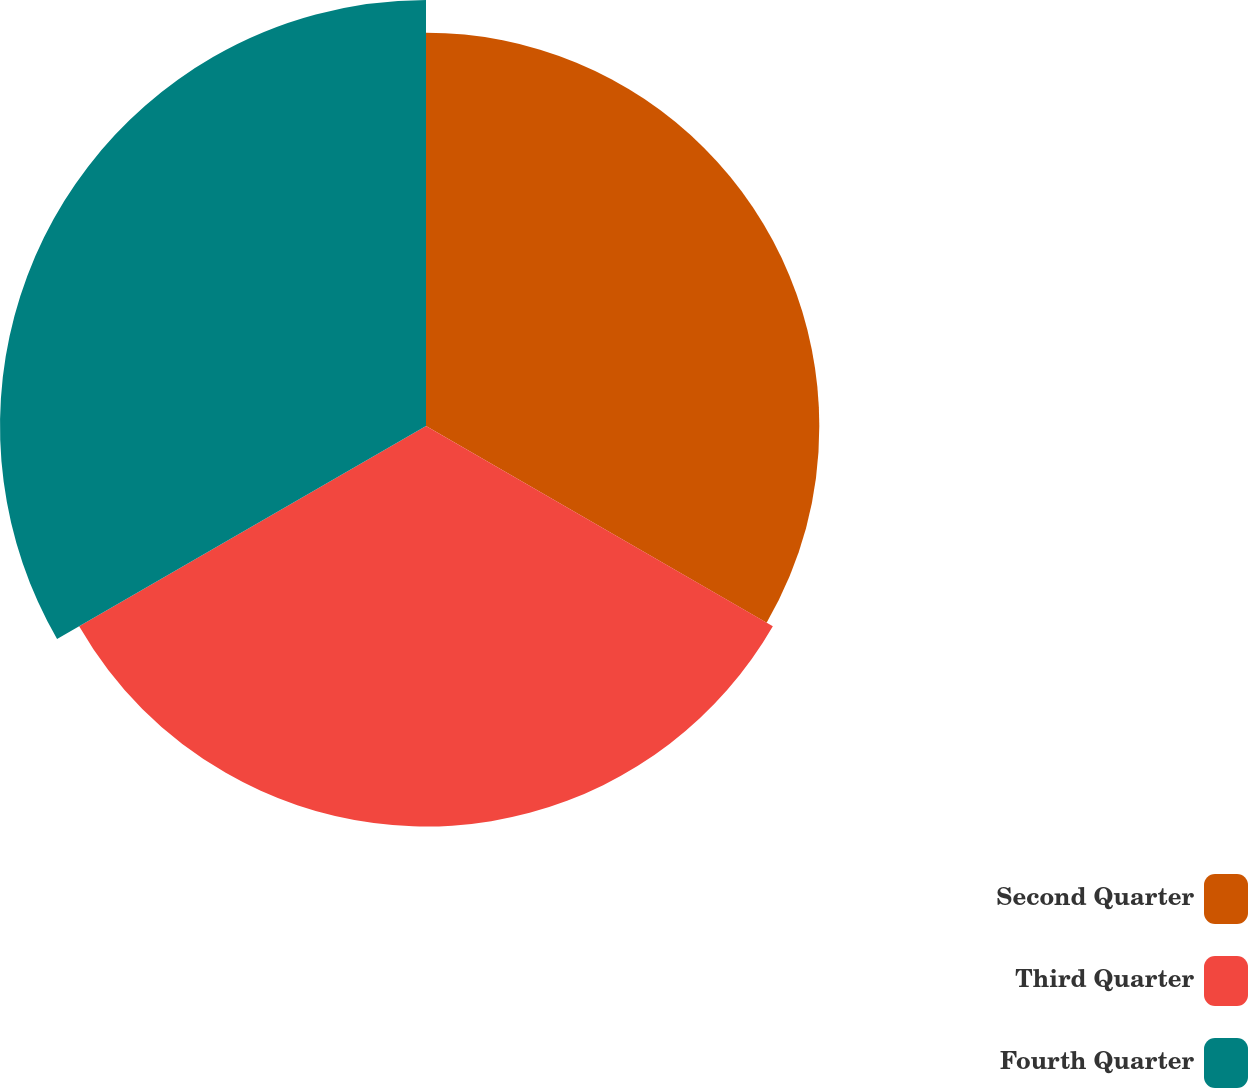<chart> <loc_0><loc_0><loc_500><loc_500><pie_chart><fcel>Second Quarter<fcel>Third Quarter<fcel>Fourth Quarter<nl><fcel>32.24%<fcel>32.83%<fcel>34.92%<nl></chart> 